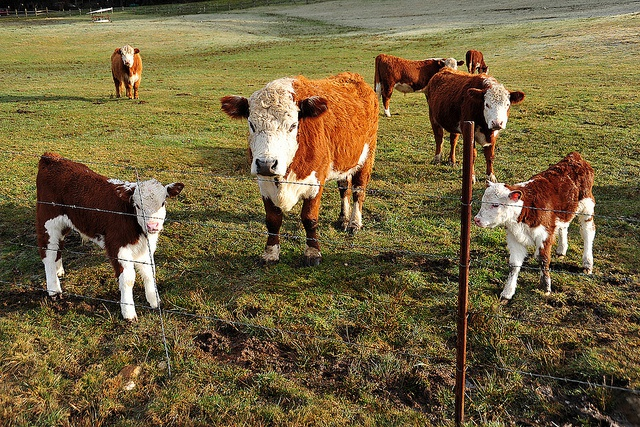Describe the objects in this image and their specific colors. I can see cow in black, red, ivory, and brown tones, cow in black, white, darkgray, and maroon tones, cow in black, maroon, ivory, and darkgray tones, cow in black, maroon, ivory, and olive tones, and cow in black, maroon, and brown tones in this image. 